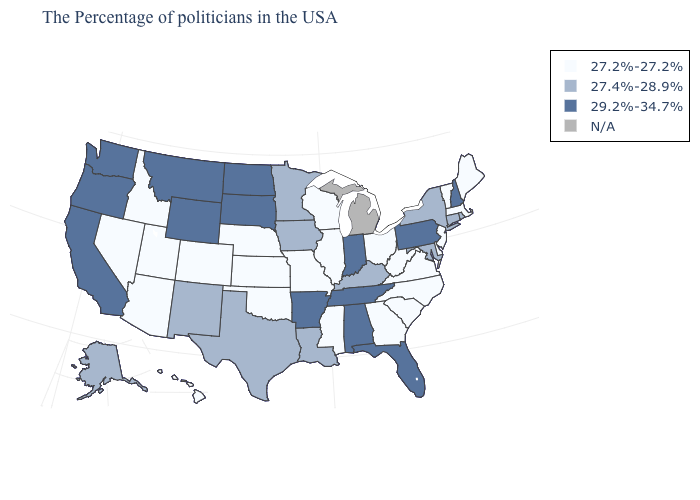Which states hav the highest value in the Northeast?
Short answer required. New Hampshire, Pennsylvania. What is the value of Montana?
Keep it brief. 29.2%-34.7%. Name the states that have a value in the range 27.2%-27.2%?
Write a very short answer. Maine, Massachusetts, Vermont, New Jersey, Delaware, Virginia, North Carolina, South Carolina, West Virginia, Ohio, Georgia, Wisconsin, Illinois, Mississippi, Missouri, Kansas, Nebraska, Oklahoma, Colorado, Utah, Arizona, Idaho, Nevada, Hawaii. Does Georgia have the lowest value in the USA?
Short answer required. Yes. What is the lowest value in the USA?
Short answer required. 27.2%-27.2%. Name the states that have a value in the range 29.2%-34.7%?
Be succinct. New Hampshire, Pennsylvania, Florida, Indiana, Alabama, Tennessee, Arkansas, South Dakota, North Dakota, Wyoming, Montana, California, Washington, Oregon. Name the states that have a value in the range N/A?
Short answer required. Michigan. Name the states that have a value in the range 27.4%-28.9%?
Be succinct. Rhode Island, Connecticut, New York, Maryland, Kentucky, Louisiana, Minnesota, Iowa, Texas, New Mexico, Alaska. Which states have the lowest value in the USA?
Write a very short answer. Maine, Massachusetts, Vermont, New Jersey, Delaware, Virginia, North Carolina, South Carolina, West Virginia, Ohio, Georgia, Wisconsin, Illinois, Mississippi, Missouri, Kansas, Nebraska, Oklahoma, Colorado, Utah, Arizona, Idaho, Nevada, Hawaii. What is the lowest value in the South?
Give a very brief answer. 27.2%-27.2%. Name the states that have a value in the range 27.2%-27.2%?
Keep it brief. Maine, Massachusetts, Vermont, New Jersey, Delaware, Virginia, North Carolina, South Carolina, West Virginia, Ohio, Georgia, Wisconsin, Illinois, Mississippi, Missouri, Kansas, Nebraska, Oklahoma, Colorado, Utah, Arizona, Idaho, Nevada, Hawaii. Which states hav the highest value in the Northeast?
Short answer required. New Hampshire, Pennsylvania. Which states have the lowest value in the Northeast?
Write a very short answer. Maine, Massachusetts, Vermont, New Jersey. Does Oklahoma have the highest value in the USA?
Quick response, please. No. 